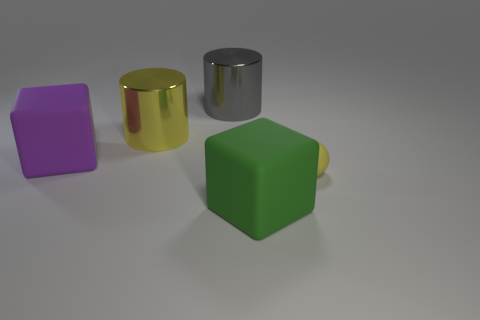Are there any other objects in the image that share a similar shape to the gray cylinder? The gold-colored object next to the gray cylinder has a similar cylindrical shape but with a different color and a reflective surface. How does the reflective surface of the gold-colored cylinder compare to that of the gray one? The gold-colored cylinder has a more reflective surface, creating a mirror-like exterior that reflects the environment, unlike the gray cylinder's less reflective, metallic sheen. 